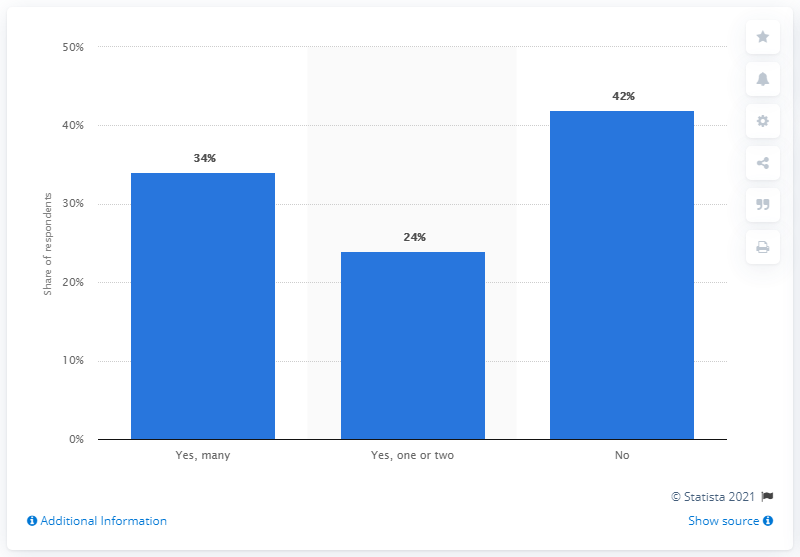Give some essential details in this illustration. Please provide the percentage value for the "No" category in the range of 42.. The average of all the data given in the chart is 33.33. 